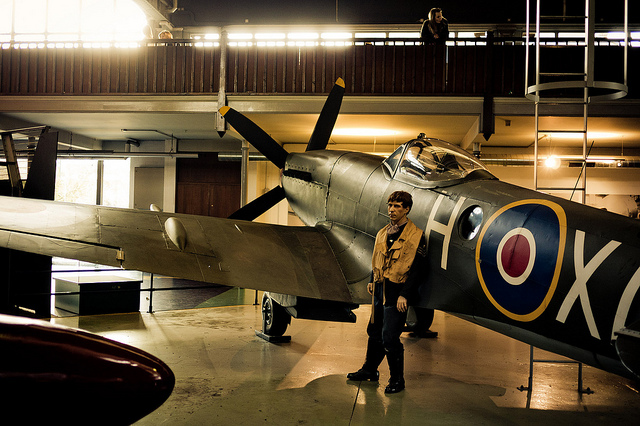Please identify all text content in this image. HOX 